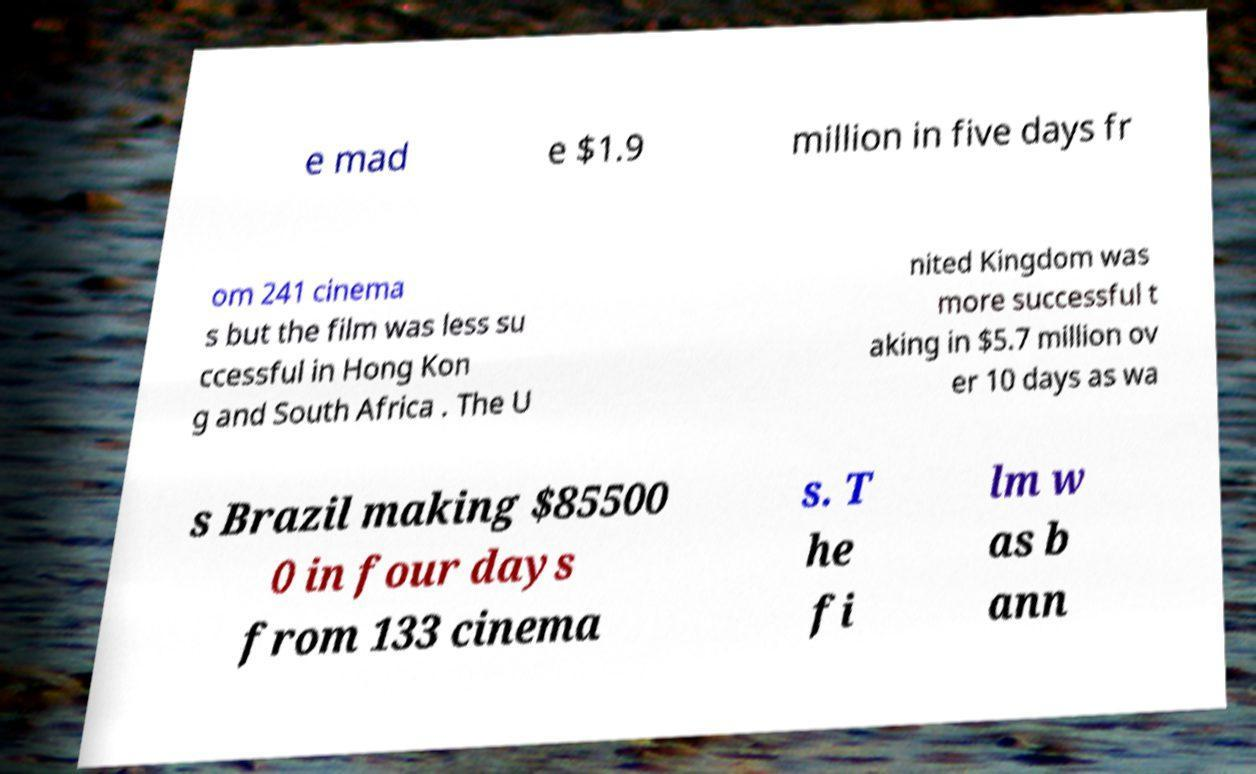Please identify and transcribe the text found in this image. e mad e $1.9 million in five days fr om 241 cinema s but the film was less su ccessful in Hong Kon g and South Africa . The U nited Kingdom was more successful t aking in $5.7 million ov er 10 days as wa s Brazil making $85500 0 in four days from 133 cinema s. T he fi lm w as b ann 